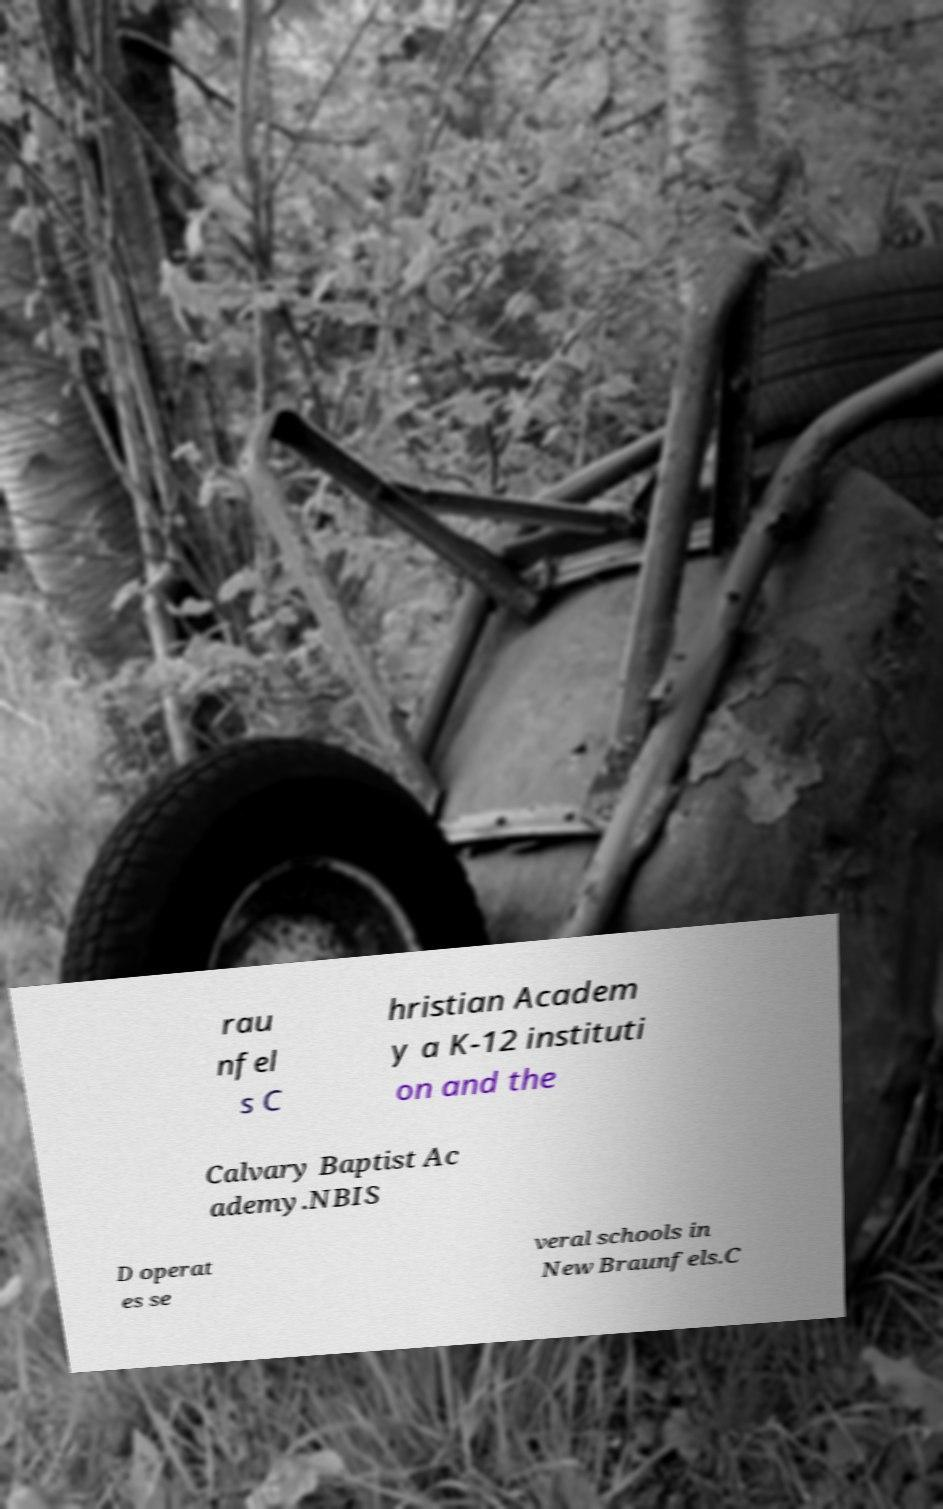I need the written content from this picture converted into text. Can you do that? rau nfel s C hristian Academ y a K-12 instituti on and the Calvary Baptist Ac ademy.NBIS D operat es se veral schools in New Braunfels.C 